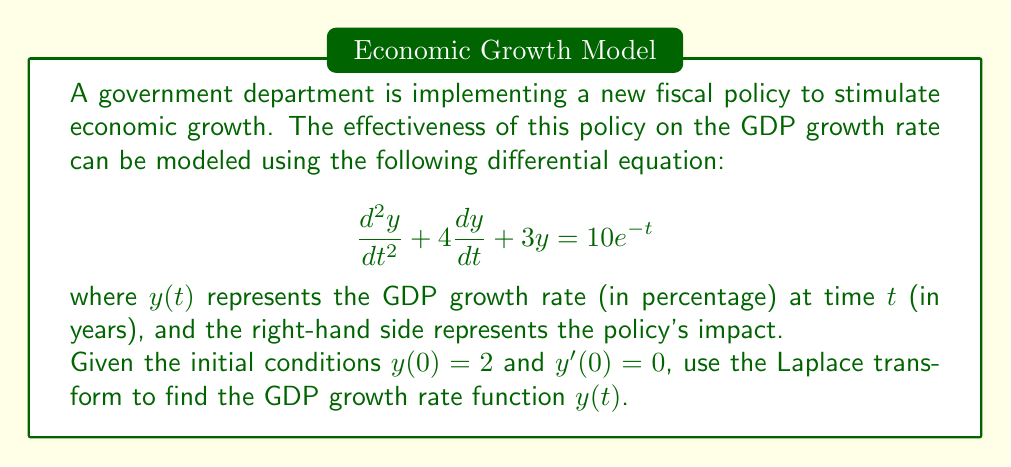Teach me how to tackle this problem. Let's solve this step-by-step using the Laplace transform:

1) Take the Laplace transform of both sides of the equation:
   $$\mathcal{L}\{y''(t) + 4y'(t) + 3y(t)\} = \mathcal{L}\{10e^{-t}\}$$

2) Using Laplace transform properties:
   $$s^2Y(s) - sy(0) - y'(0) + 4(sY(s) - y(0)) + 3Y(s) = \frac{10}{s+1}$$

3) Substitute the initial conditions $y(0) = 2$ and $y'(0) = 0$:
   $$s^2Y(s) - 2s + 4sY(s) - 8 + 3Y(s) = \frac{10}{s+1}$$

4) Collect terms with $Y(s)$:
   $$(s^2 + 4s + 3)Y(s) = \frac{10}{s+1} + 2s + 8$$

5) Solve for $Y(s)$:
   $$Y(s) = \frac{10}{(s+1)(s^2 + 4s + 3)} + \frac{2s + 8}{s^2 + 4s + 3}$$

6) Decompose into partial fractions:
   $$Y(s) = \frac{A}{s+1} + \frac{B}{s+1} + \frac{Cs+D}{s^2 + 4s + 3}$$

   Where $A = 1$, $B = 1$, $C = 1$, and $D = 3$

7) Take the inverse Laplace transform:
   $$y(t) = e^{-t} + e^{-t} + e^{-2t}(cos(t) + 3sin(t))$$

8) Simplify:
   $$y(t) = 2e^{-t} + e^{-2t}(cos(t) + 3sin(t))$$

This is the GDP growth rate function over time.
Answer: $y(t) = 2e^{-t} + e^{-2t}(cos(t) + 3sin(t))$ 